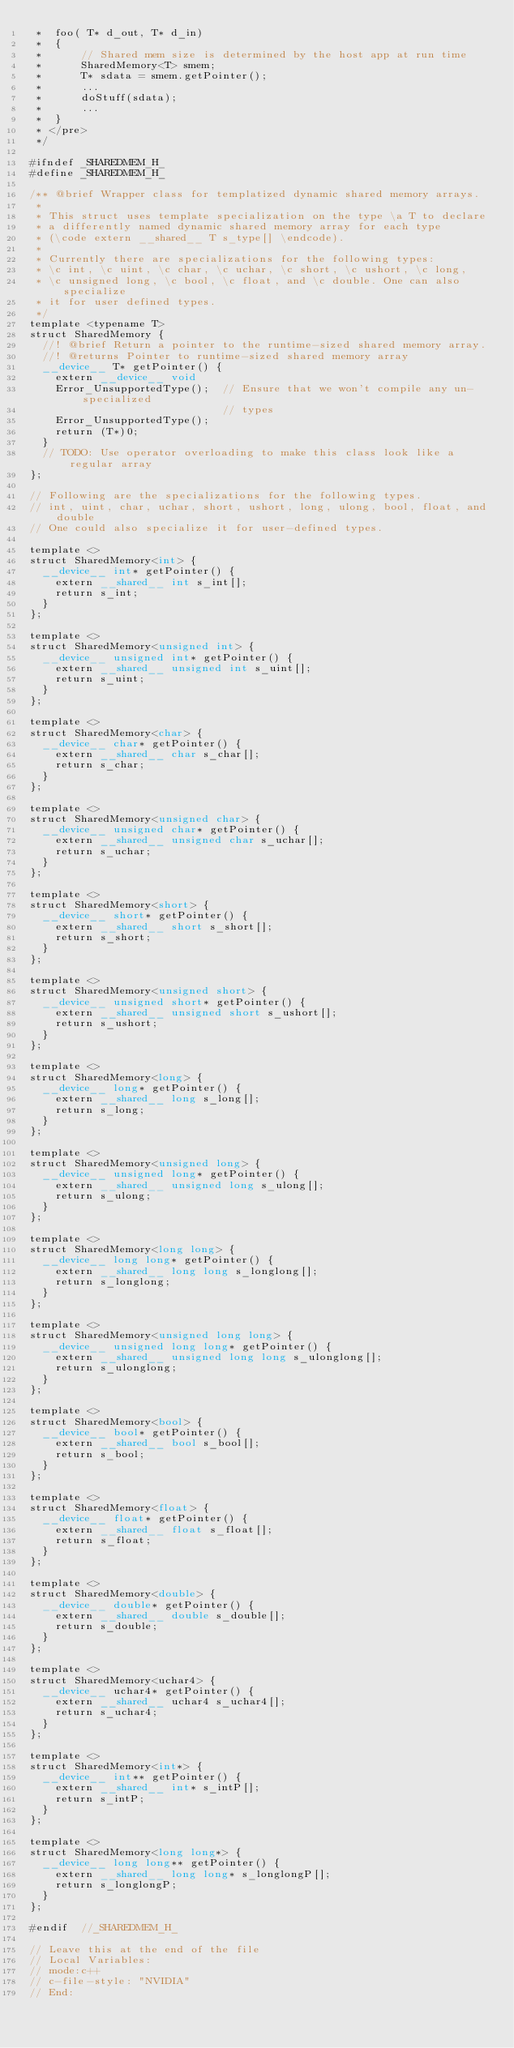Convert code to text. <code><loc_0><loc_0><loc_500><loc_500><_Cuda_> *  foo( T* d_out, T* d_in)
 *  {
 *      // Shared mem size is determined by the host app at run time
 *      SharedMemory<T> smem;
 *      T* sdata = smem.getPointer();
 *      ...
 *      doStuff(sdata);
 *      ...
 *  }
 * </pre>
 */

#ifndef _SHAREDMEM_H_
#define _SHAREDMEM_H_

/** @brief Wrapper class for templatized dynamic shared memory arrays.
 *
 * This struct uses template specialization on the type \a T to declare
 * a differently named dynamic shared memory array for each type
 * (\code extern __shared__ T s_type[] \endcode).
 *
 * Currently there are specializations for the following types:
 * \c int, \c uint, \c char, \c uchar, \c short, \c ushort, \c long,
 * \c unsigned long, \c bool, \c float, and \c double. One can also specialize
 * it for user defined types.
 */
template <typename T>
struct SharedMemory {
  //! @brief Return a pointer to the runtime-sized shared memory array.
  //! @returns Pointer to runtime-sized shared memory array
  __device__ T* getPointer() {
    extern __device__ void
    Error_UnsupportedType();  // Ensure that we won't compile any un-specialized
                              // types
    Error_UnsupportedType();
    return (T*)0;
  }
  // TODO: Use operator overloading to make this class look like a regular array
};

// Following are the specializations for the following types.
// int, uint, char, uchar, short, ushort, long, ulong, bool, float, and double
// One could also specialize it for user-defined types.

template <>
struct SharedMemory<int> {
  __device__ int* getPointer() {
    extern __shared__ int s_int[];
    return s_int;
  }
};

template <>
struct SharedMemory<unsigned int> {
  __device__ unsigned int* getPointer() {
    extern __shared__ unsigned int s_uint[];
    return s_uint;
  }
};

template <>
struct SharedMemory<char> {
  __device__ char* getPointer() {
    extern __shared__ char s_char[];
    return s_char;
  }
};

template <>
struct SharedMemory<unsigned char> {
  __device__ unsigned char* getPointer() {
    extern __shared__ unsigned char s_uchar[];
    return s_uchar;
  }
};

template <>
struct SharedMemory<short> {
  __device__ short* getPointer() {
    extern __shared__ short s_short[];
    return s_short;
  }
};

template <>
struct SharedMemory<unsigned short> {
  __device__ unsigned short* getPointer() {
    extern __shared__ unsigned short s_ushort[];
    return s_ushort;
  }
};

template <>
struct SharedMemory<long> {
  __device__ long* getPointer() {
    extern __shared__ long s_long[];
    return s_long;
  }
};

template <>
struct SharedMemory<unsigned long> {
  __device__ unsigned long* getPointer() {
    extern __shared__ unsigned long s_ulong[];
    return s_ulong;
  }
};

template <>
struct SharedMemory<long long> {
  __device__ long long* getPointer() {
    extern __shared__ long long s_longlong[];
    return s_longlong;
  }
};

template <>
struct SharedMemory<unsigned long long> {
  __device__ unsigned long long* getPointer() {
    extern __shared__ unsigned long long s_ulonglong[];
    return s_ulonglong;
  }
};

template <>
struct SharedMemory<bool> {
  __device__ bool* getPointer() {
    extern __shared__ bool s_bool[];
    return s_bool;
  }
};

template <>
struct SharedMemory<float> {
  __device__ float* getPointer() {
    extern __shared__ float s_float[];
    return s_float;
  }
};

template <>
struct SharedMemory<double> {
  __device__ double* getPointer() {
    extern __shared__ double s_double[];
    return s_double;
  }
};

template <>
struct SharedMemory<uchar4> {
  __device__ uchar4* getPointer() {
    extern __shared__ uchar4 s_uchar4[];
    return s_uchar4;
  }
};

template <>
struct SharedMemory<int*> {
  __device__ int** getPointer() {
    extern __shared__ int* s_intP[];
    return s_intP;
  }
};

template <>
struct SharedMemory<long long*> {
  __device__ long long** getPointer() {
    extern __shared__ long long* s_longlongP[];
    return s_longlongP;
  }
};

#endif  //_SHAREDMEM_H_

// Leave this at the end of the file
// Local Variables:
// mode:c++
// c-file-style: "NVIDIA"
// End:
</code> 